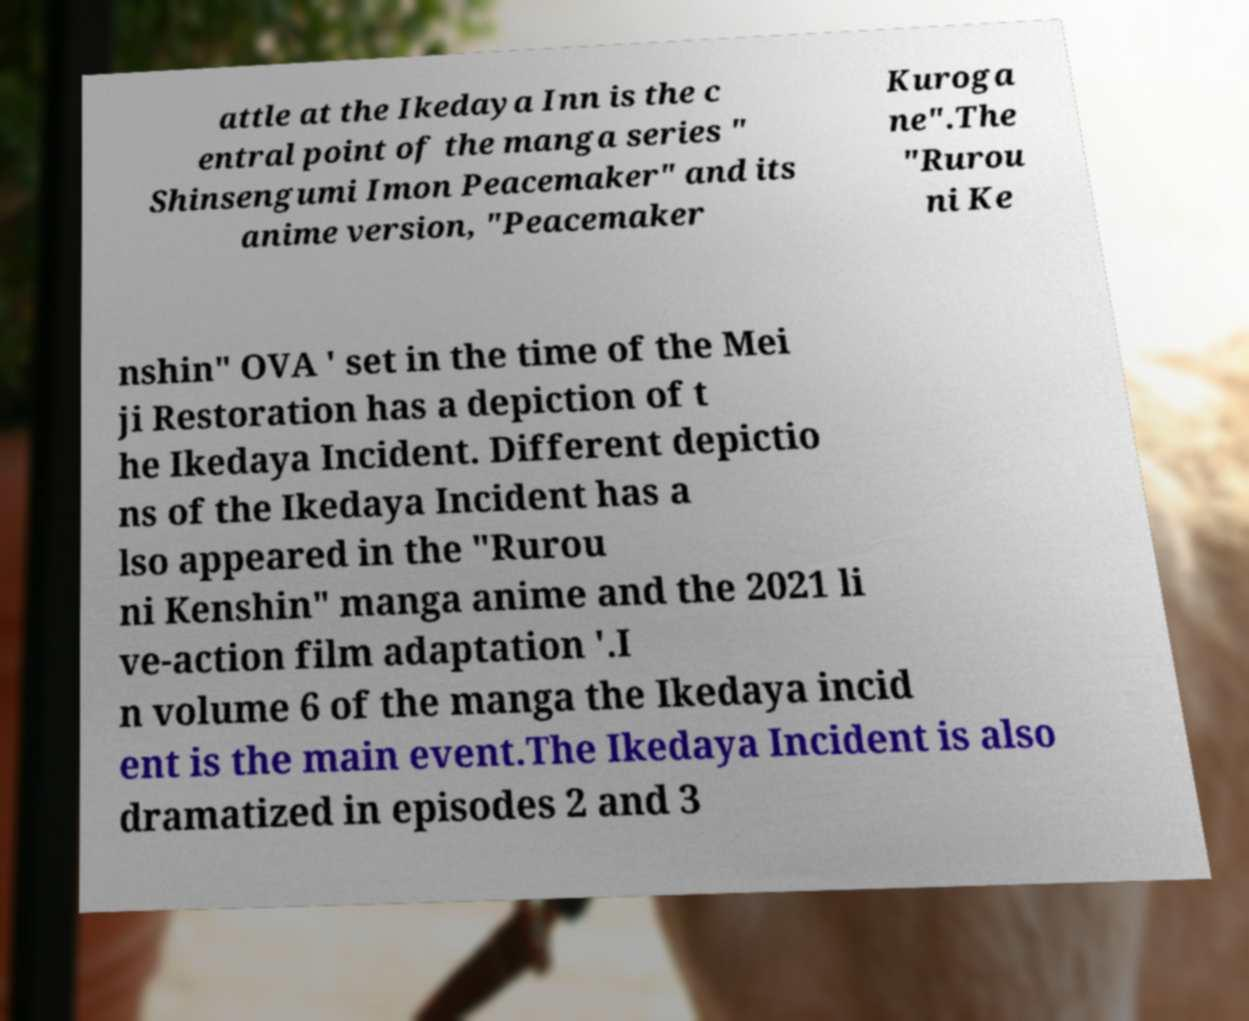Can you read and provide the text displayed in the image?This photo seems to have some interesting text. Can you extract and type it out for me? attle at the Ikedaya Inn is the c entral point of the manga series " Shinsengumi Imon Peacemaker" and its anime version, "Peacemaker Kuroga ne".The "Rurou ni Ke nshin" OVA ' set in the time of the Mei ji Restoration has a depiction of t he Ikedaya Incident. Different depictio ns of the Ikedaya Incident has a lso appeared in the "Rurou ni Kenshin" manga anime and the 2021 li ve-action film adaptation '.I n volume 6 of the manga the Ikedaya incid ent is the main event.The Ikedaya Incident is also dramatized in episodes 2 and 3 